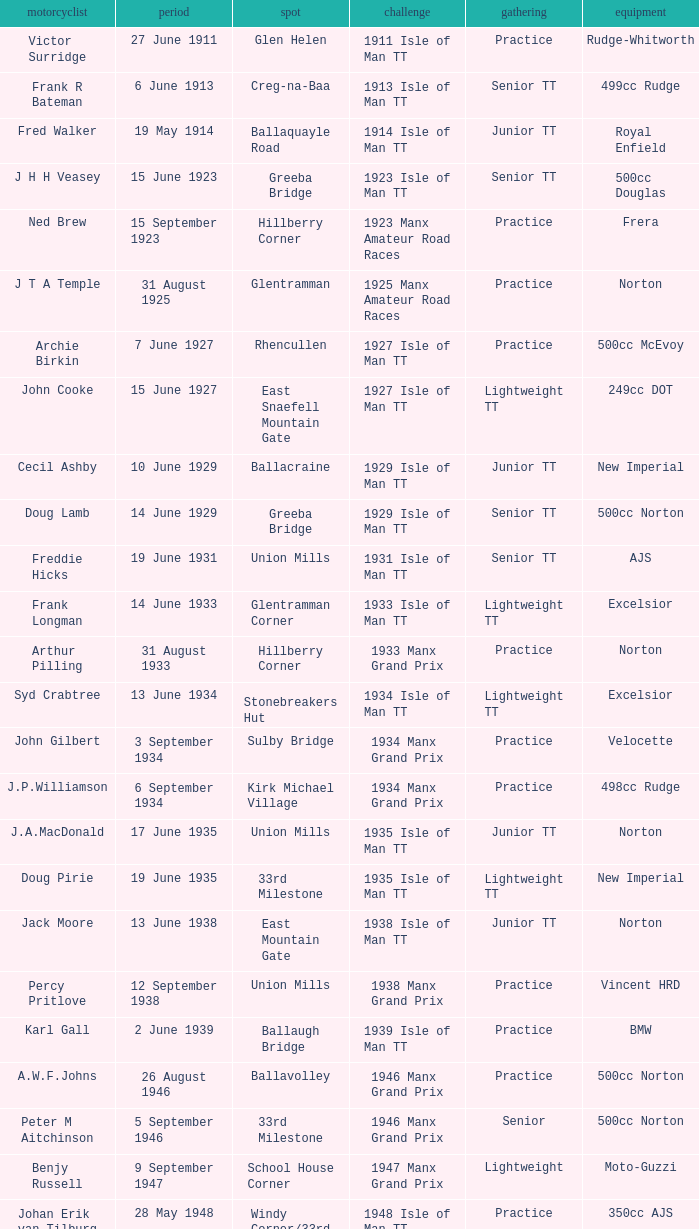Harry l Stephen rides a Norton machine on what date? 8 June 1953. 